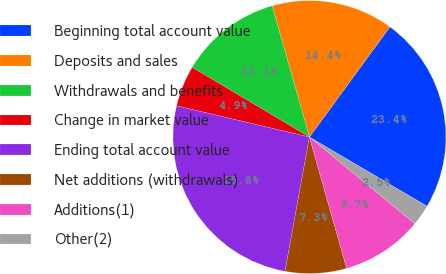Convert chart. <chart><loc_0><loc_0><loc_500><loc_500><pie_chart><fcel>Beginning total account value<fcel>Deposits and sales<fcel>Withdrawals and benefits<fcel>Change in market value<fcel>Ending total account value<fcel>Net additions (withdrawals)<fcel>Additions(1)<fcel>Other(2)<nl><fcel>23.42%<fcel>14.45%<fcel>12.05%<fcel>4.87%<fcel>25.81%<fcel>7.26%<fcel>9.66%<fcel>2.48%<nl></chart> 